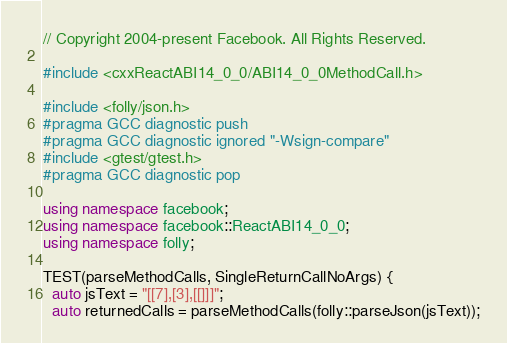Convert code to text. <code><loc_0><loc_0><loc_500><loc_500><_C++_>// Copyright 2004-present Facebook. All Rights Reserved.

#include <cxxReactABI14_0_0/ABI14_0_0MethodCall.h>

#include <folly/json.h>
#pragma GCC diagnostic push
#pragma GCC diagnostic ignored "-Wsign-compare"
#include <gtest/gtest.h>
#pragma GCC diagnostic pop

using namespace facebook;
using namespace facebook::ReactABI14_0_0;
using namespace folly;

TEST(parseMethodCalls, SingleReturnCallNoArgs) {
  auto jsText = "[[7],[3],[[]]]";
  auto returnedCalls = parseMethodCalls(folly::parseJson(jsText));</code> 